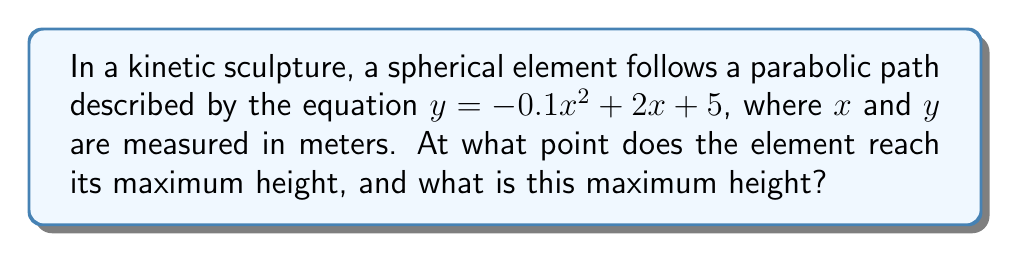Can you answer this question? To solve this problem, we'll follow these steps:

1) The parabolic path is given by $y = -0.1x^2 + 2x + 5$. This is in the form of $y = ax^2 + bx + c$, where $a = -0.1$, $b = 2$, and $c = 5$.

2) For a parabola, the x-coordinate of the vertex (which represents the maximum point for an upward-facing parabola or the minimum point for a downward-facing parabola) is given by the formula:

   $x = -\frac{b}{2a}$

3) Substituting our values:

   $x = -\frac{2}{2(-0.1)} = -\frac{2}{-0.2} = 10$

4) To find the y-coordinate (the maximum height), we substitute this x-value back into our original equation:

   $y = -0.1(10)^2 + 2(10) + 5$
   $= -0.1(100) + 20 + 5$
   $= -10 + 20 + 5$
   $= 15$

5) Therefore, the maximum point occurs at (10, 15).

[asy]
import graph;
size(200,200);
real f(real x) {return -0.1x^2+2x+5;}
draw(graph(f,0,20),blue);
dot((10,15),red);
label("(10, 15)",(10,15),NE);
xaxis("x",0,20);
yaxis("y",0,20);
[/asy]
Answer: (10, 15) 